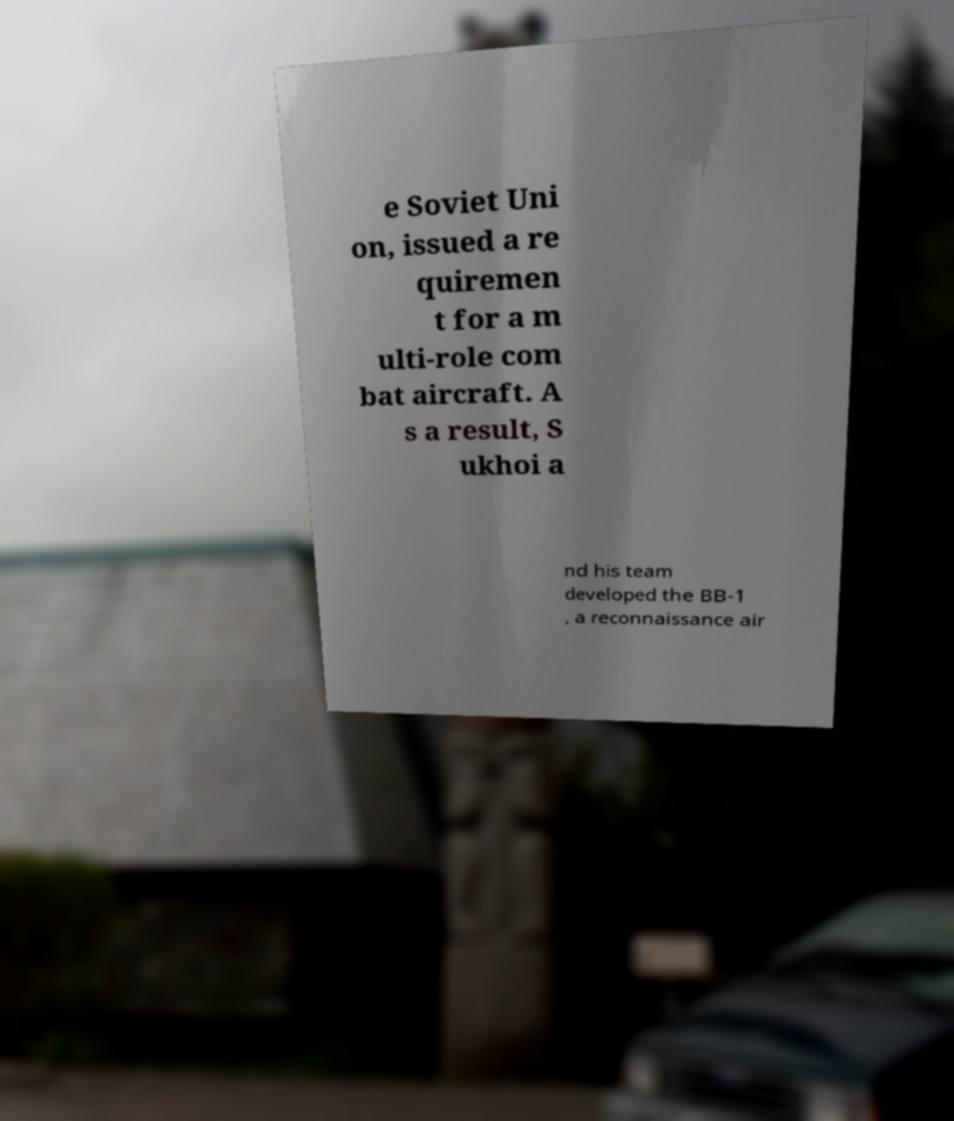Can you accurately transcribe the text from the provided image for me? e Soviet Uni on, issued a re quiremen t for a m ulti-role com bat aircraft. A s a result, S ukhoi a nd his team developed the BB-1 , a reconnaissance air 